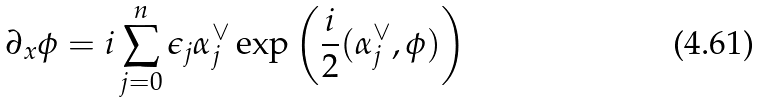<formula> <loc_0><loc_0><loc_500><loc_500>\partial _ { x } { \phi } = i \sum _ { j = 0 } ^ { n } \epsilon _ { j } \alpha _ { j } ^ { \vee } \exp \left ( \frac { i } { 2 } ( \alpha _ { j } ^ { \vee } , \phi ) \right )</formula> 